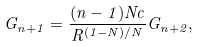<formula> <loc_0><loc_0><loc_500><loc_500>G _ { n + 1 } = \frac { ( n - 1 ) N c } { R ^ { ( 1 - N ) / N } } G _ { n + 2 } ,</formula> 